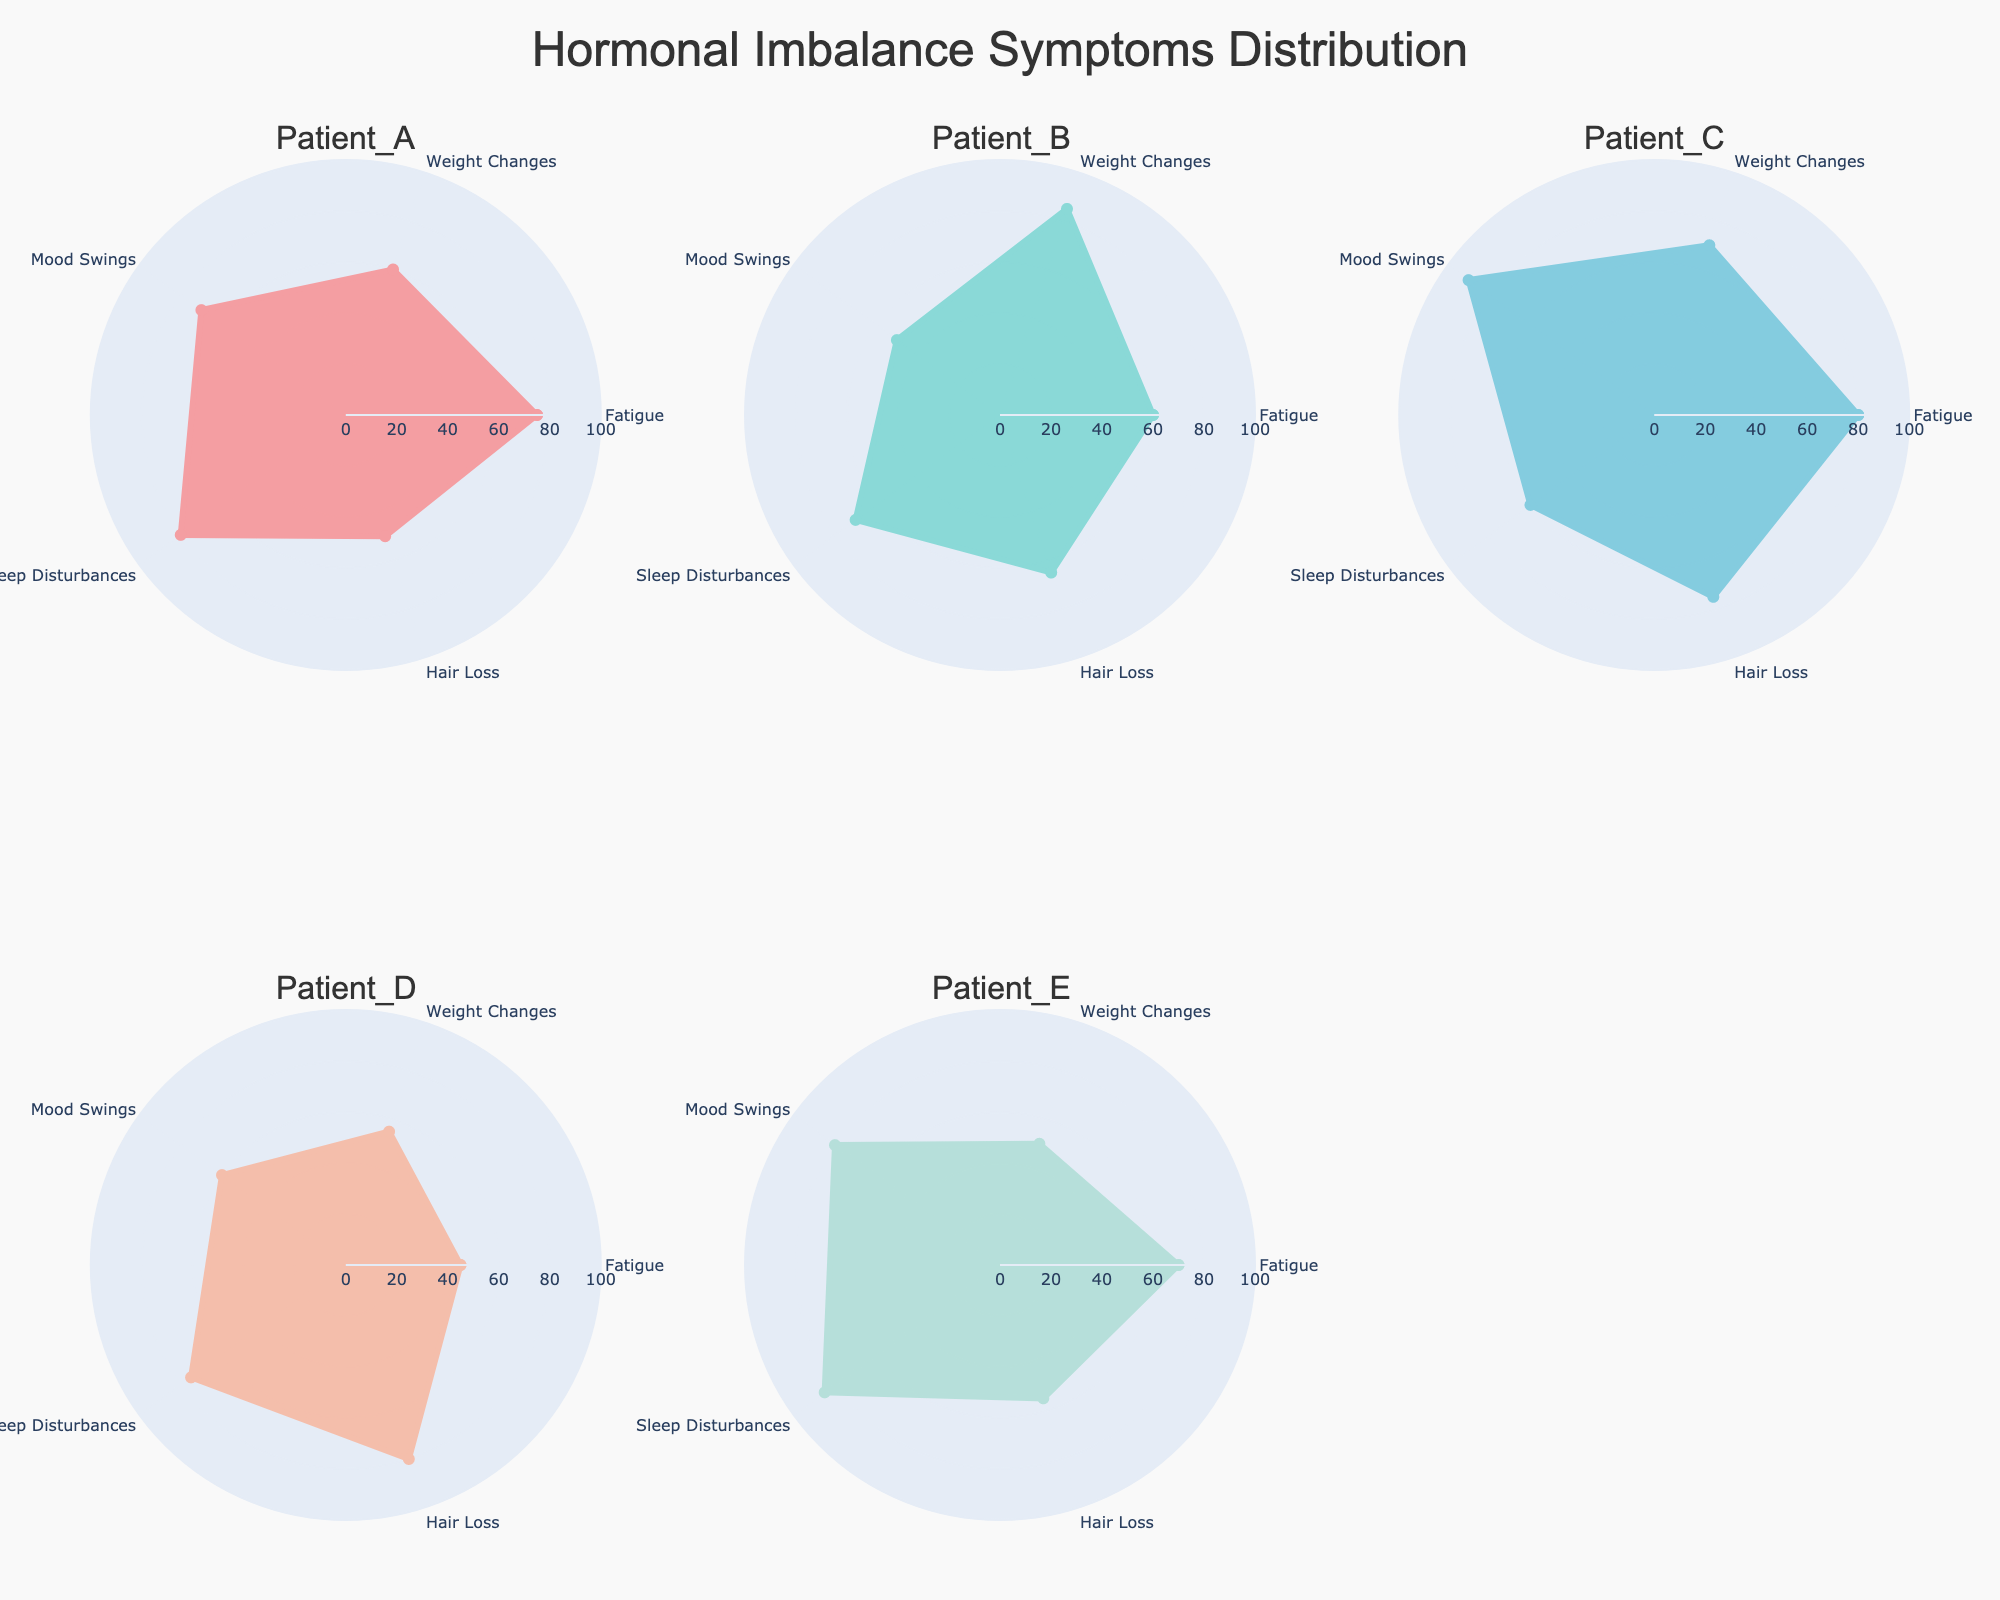Which patient has the highest value for Mood Swings? By scanning the Mood Swings axis across all radar charts, Patient C shows the highest value at 90.
Answer: Patient C What is the title of the figure? The title is located at the top of the figure, explicitly stating what it represents.
Answer: Hormonal Imbalance Symptoms Distribution Which symptom shows the least variation among patients? By visually comparing the spreads for each symptom across all patients, Hair Loss appears to have the least spread in values, ranging from 50 to 80.
Answer: Hair Loss How many different symptoms are plotted in the radar charts? Counting the number of symptoms listed on each radial axis reveals there are 5 symptoms.
Answer: 5 What is the median value for Sleep Disturbances across all patients? The values for Sleep Disturbances are 80, 70, 60, 75, and 85. Sorting these values: 60, 70, 75, 80, 85, the median is 75.
Answer: 75 Which patient has the lowest overall symptom score? Summing up the values for each patient: Patient A (75+60+70+80+50=335), Patient B (60+85+50+70+65=330), Patient C (80+70+90+60+75=375), Patient D (45+55+60+75+80=315), Patient E (70+50+80+85+55=340). Patient D has the lowest total score.
Answer: Patient D For which symptom does Patient A have the highest score compared to other patients? By comparing Patient A's values for each symptom against others', Patient A has the highest score for Sleep Disturbances at 80.
Answer: Sleep Disturbances What is the range of values for Weight Changes among all patients? The values for Weight Changes are 60, 85, 70, 55, and 50. The range is calculated as the maximum value (85) minus the minimum value (50), which is 35.
Answer: 35 Which patient has the most balanced radar chart, meaning their scores are more evenly distributed? By visually comparing the balance among all radar charts, Patient E shows relatively even distribution across the symptoms.
Answer: Patient E 